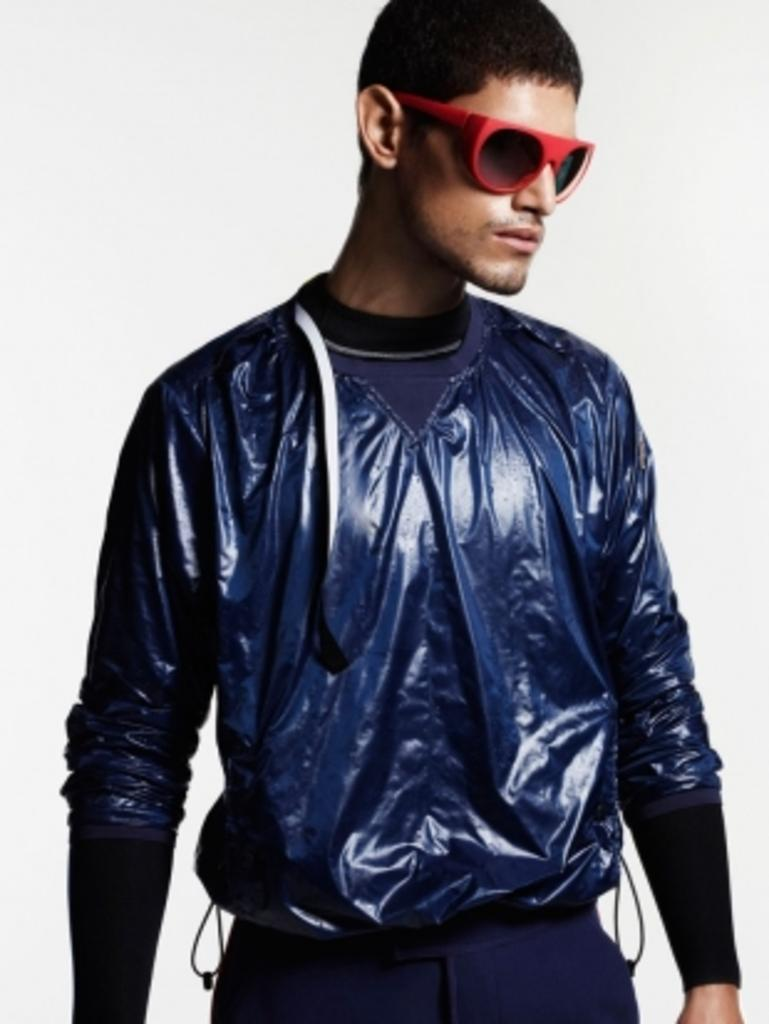Who is present in the image? There is a man in the image. What is the man wearing on his face? The man is wearing goggles. What is the man's posture in the image? The man is standing. What is the color of the background in the image? The background in the image is white. What type of event is taking place in the image involving sticks? There is no event involving sticks present in the image; it only features a man wearing goggles and standing against a white background. 